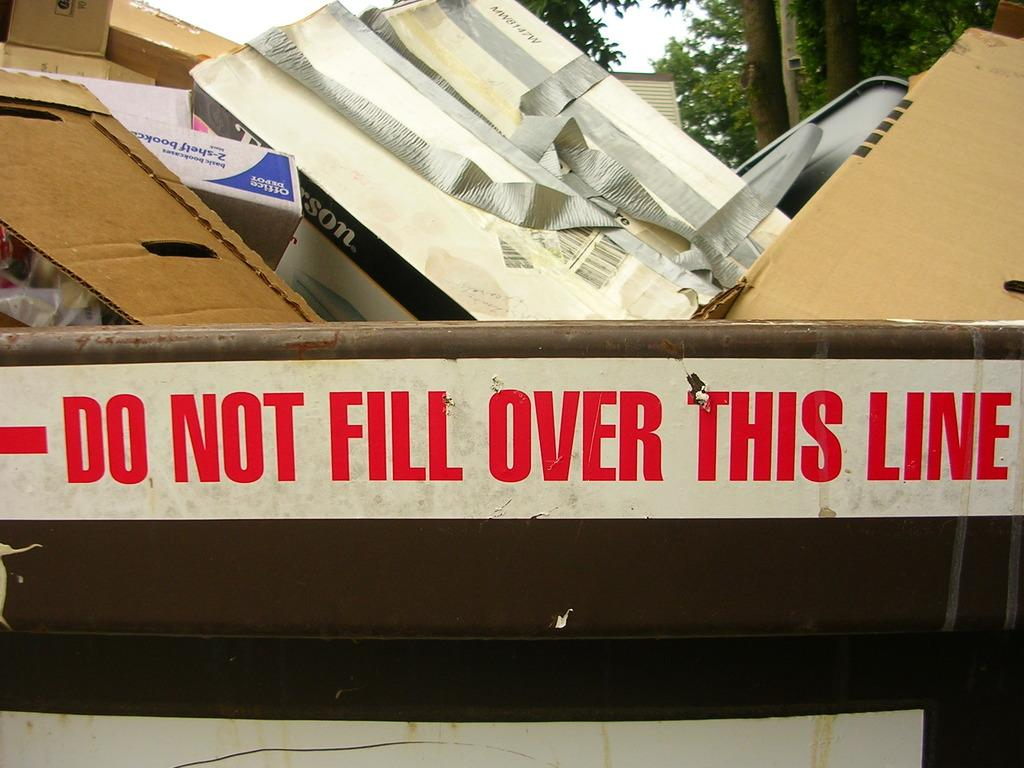<image>
Offer a succinct explanation of the picture presented. Do not fill over this line sign for a trash can 